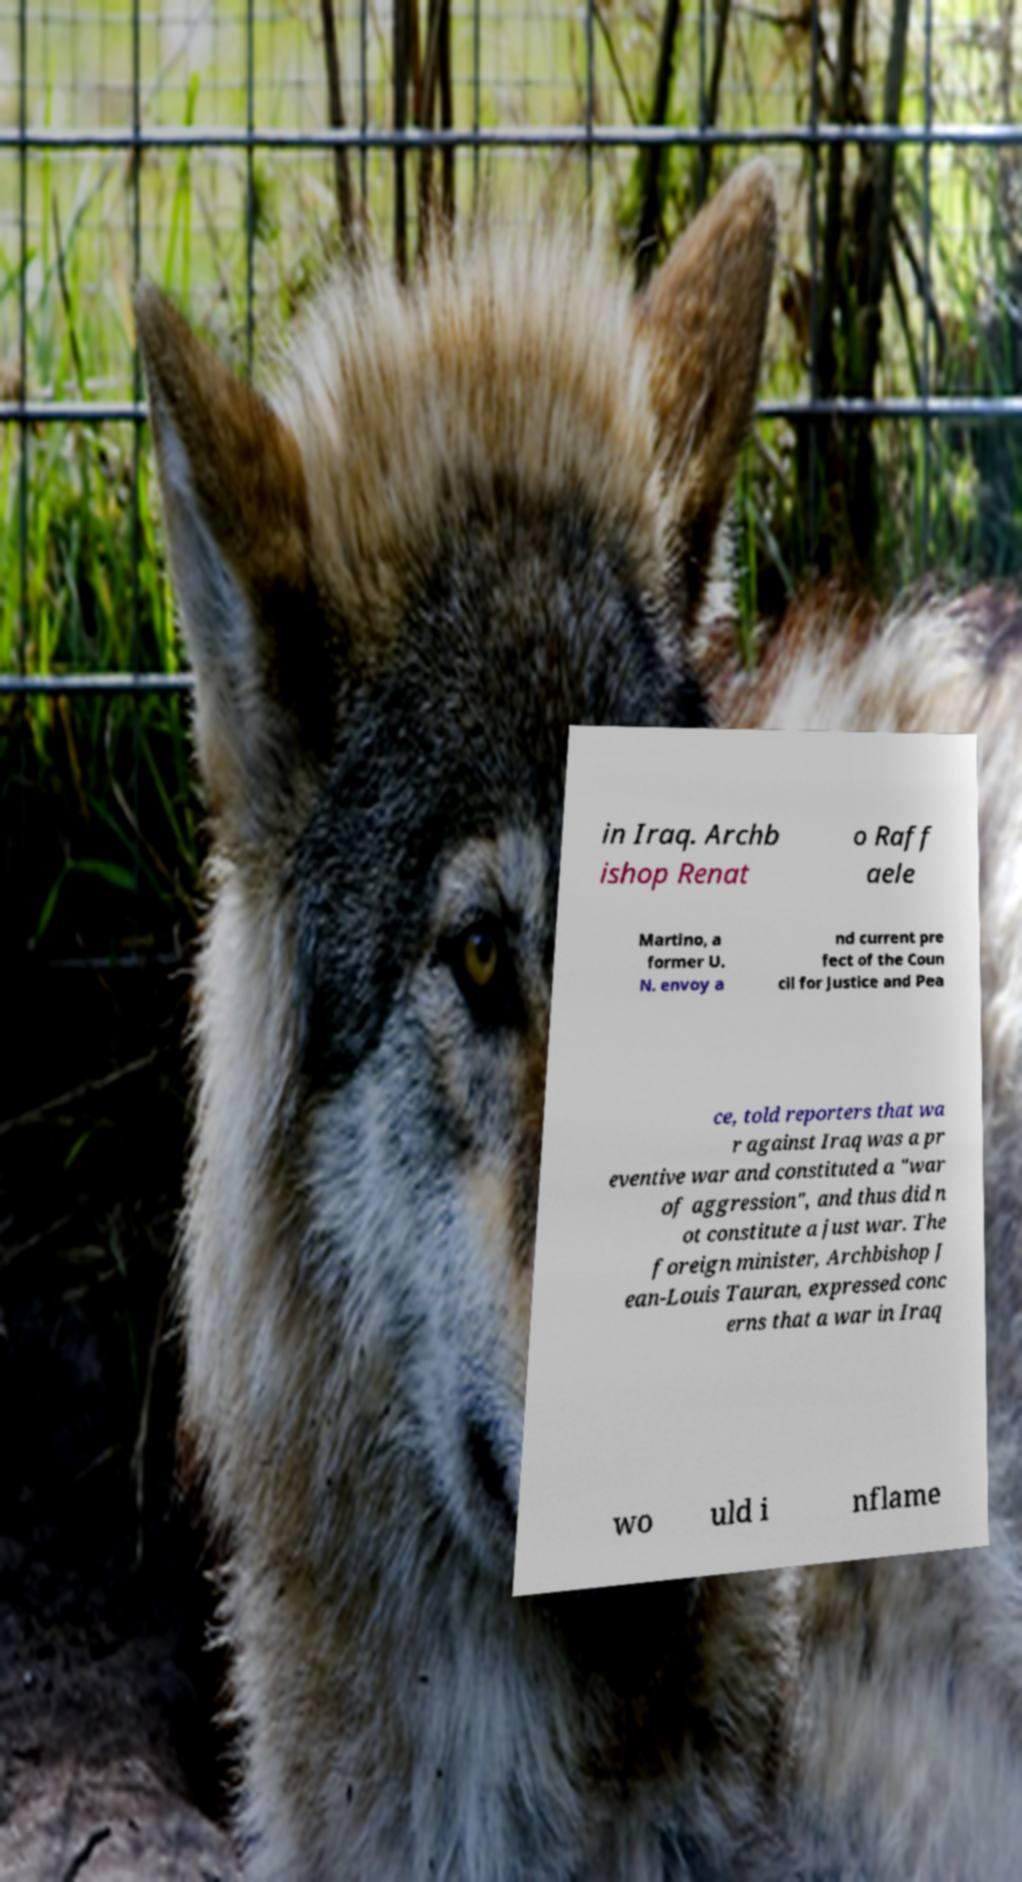Please read and relay the text visible in this image. What does it say? in Iraq. Archb ishop Renat o Raff aele Martino, a former U. N. envoy a nd current pre fect of the Coun cil for Justice and Pea ce, told reporters that wa r against Iraq was a pr eventive war and constituted a "war of aggression", and thus did n ot constitute a just war. The foreign minister, Archbishop J ean-Louis Tauran, expressed conc erns that a war in Iraq wo uld i nflame 